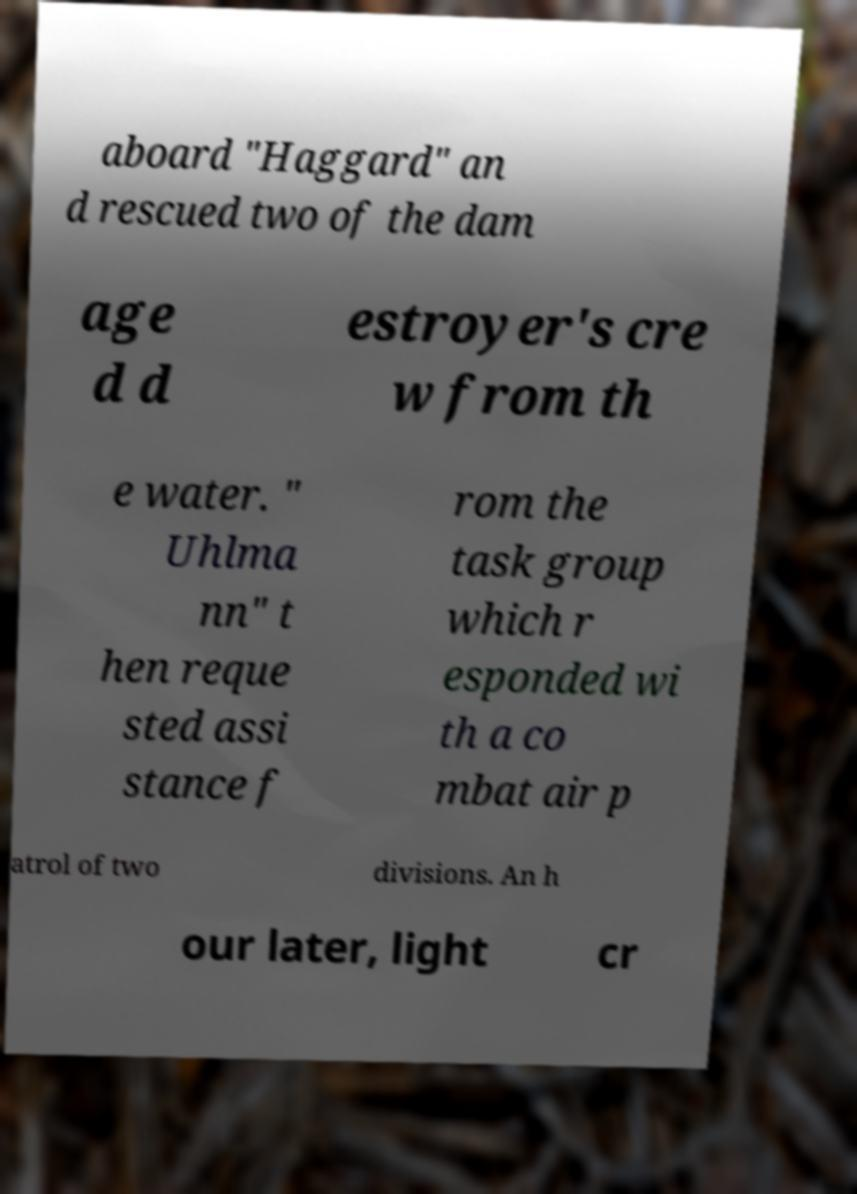Can you read and provide the text displayed in the image?This photo seems to have some interesting text. Can you extract and type it out for me? aboard "Haggard" an d rescued two of the dam age d d estroyer's cre w from th e water. " Uhlma nn" t hen reque sted assi stance f rom the task group which r esponded wi th a co mbat air p atrol of two divisions. An h our later, light cr 